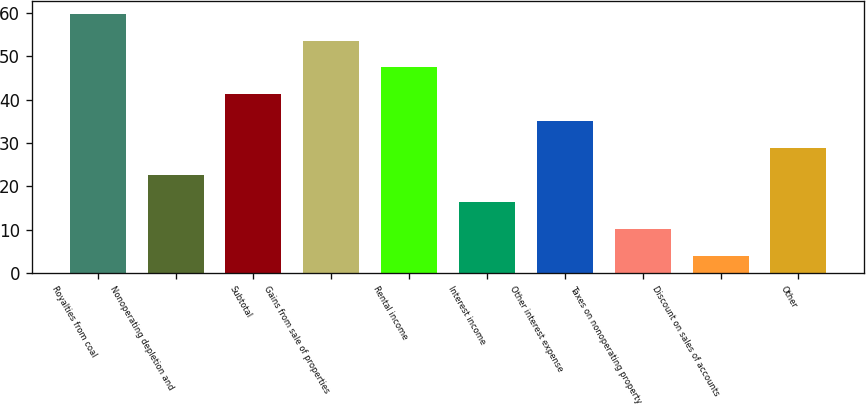Convert chart to OTSL. <chart><loc_0><loc_0><loc_500><loc_500><bar_chart><fcel>Royalties from coal<fcel>Nonoperating depletion and<fcel>Subtotal<fcel>Gains from sale of properties<fcel>Rental income<fcel>Interest income<fcel>Other interest expense<fcel>Taxes on nonoperating property<fcel>Discount on sales of accounts<fcel>Other<nl><fcel>59.8<fcel>22.6<fcel>41.2<fcel>53.6<fcel>47.4<fcel>16.4<fcel>35<fcel>10.2<fcel>4<fcel>28.8<nl></chart> 